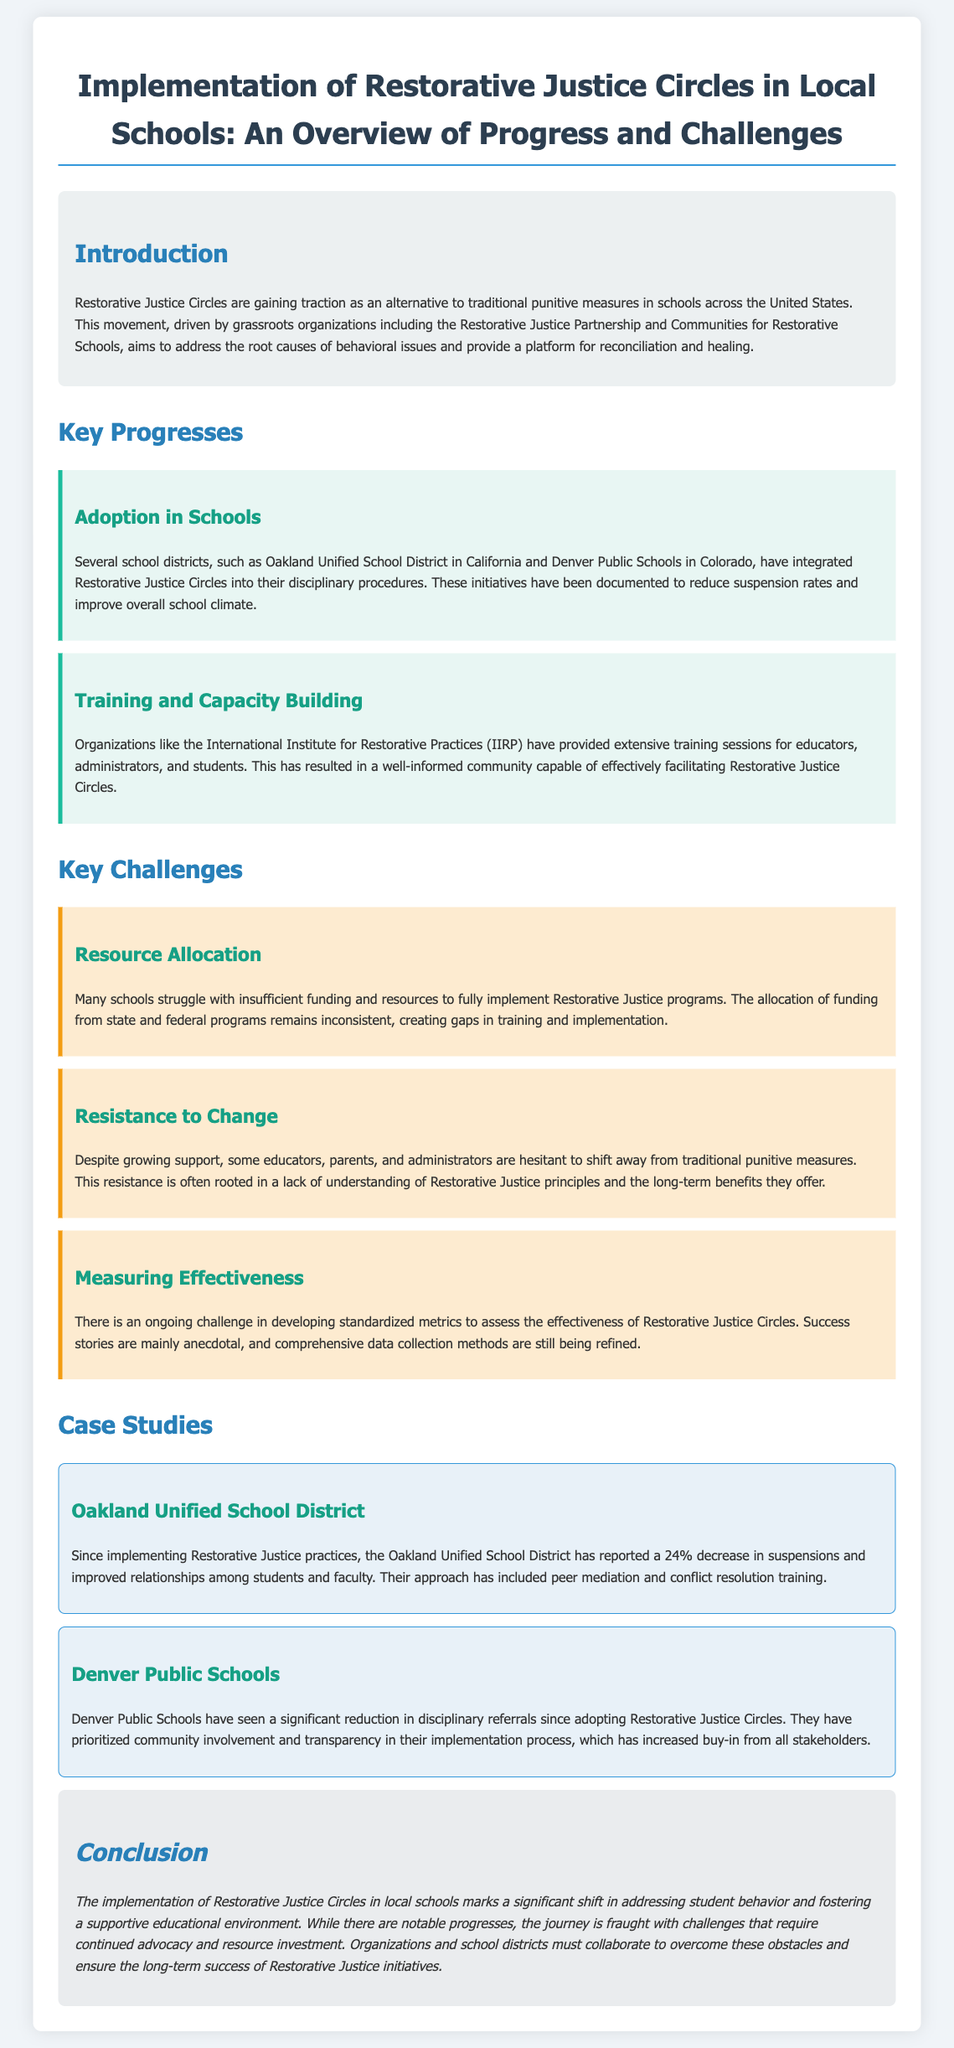What are Restorative Justice Circles? The document defines Restorative Justice Circles as an alternative to traditional punitive measures in schools, aimed at addressing root causes of behavioral issues and promoting reconciliation.
Answer: An alternative to traditional punitive measures Which organizations are driving the movement? The document mentions the Restorative Justice Partnership and Communities for Restorative Schools as key organizations driving this movement.
Answer: Restorative Justice Partnership and Communities for Restorative Schools What percentage decrease in suspensions was reported by Oakland Unified School District? The document states that the Oakland Unified School District reported a 24% decrease in suspensions since implementing Restorative Justice practices.
Answer: 24% What major challenge does the document mention regarding funding? The document indicates that many schools struggle with insufficient funding and resources for implementing Restorative Justice programs.
Answer: Insufficient funding and resources What aspect of training is highlighted as a progress? The document highlights that extensive training sessions have been provided for educators, administrators, and students.
Answer: Extensive training sessions How have Denver Public Schools engaged their community? The document states that they have prioritized community involvement and transparency in their implementation process.
Answer: Community involvement and transparency What is a key challenge in evaluating the success of Restorative Justice Circles? The document points out the ongoing challenge of developing standardized metrics to assess the effectiveness of Restorative Justice Circles.
Answer: Developing standardized metrics What is the main goal of the initiatives mentioned? The document describes the goal of these initiatives as fostering a supportive educational environment.
Answer: Fostering a supportive educational environment 